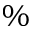<formula> <loc_0><loc_0><loc_500><loc_500>\%</formula> 